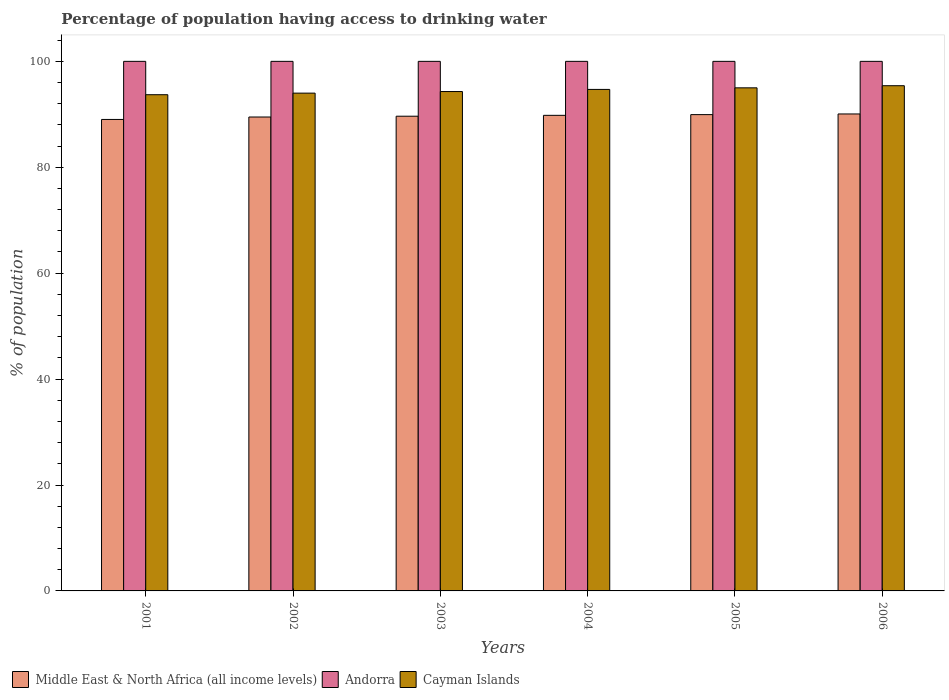How many groups of bars are there?
Offer a very short reply. 6. What is the percentage of population having access to drinking water in Andorra in 2001?
Keep it short and to the point. 100. Across all years, what is the maximum percentage of population having access to drinking water in Cayman Islands?
Your answer should be very brief. 95.4. Across all years, what is the minimum percentage of population having access to drinking water in Middle East & North Africa (all income levels)?
Offer a very short reply. 89.03. In which year was the percentage of population having access to drinking water in Andorra minimum?
Ensure brevity in your answer.  2001. What is the total percentage of population having access to drinking water in Cayman Islands in the graph?
Your answer should be compact. 567.1. What is the difference between the percentage of population having access to drinking water in Middle East & North Africa (all income levels) in 2002 and that in 2006?
Provide a short and direct response. -0.58. What is the average percentage of population having access to drinking water in Middle East & North Africa (all income levels) per year?
Keep it short and to the point. 89.66. In the year 2003, what is the difference between the percentage of population having access to drinking water in Andorra and percentage of population having access to drinking water in Middle East & North Africa (all income levels)?
Provide a short and direct response. 10.36. In how many years, is the percentage of population having access to drinking water in Cayman Islands greater than 8 %?
Ensure brevity in your answer.  6. What is the ratio of the percentage of population having access to drinking water in Andorra in 2001 to that in 2005?
Provide a short and direct response. 1. Is the difference between the percentage of population having access to drinking water in Andorra in 2002 and 2004 greater than the difference between the percentage of population having access to drinking water in Middle East & North Africa (all income levels) in 2002 and 2004?
Your answer should be very brief. Yes. What is the difference between the highest and the lowest percentage of population having access to drinking water in Middle East & North Africa (all income levels)?
Offer a terse response. 1.04. What does the 3rd bar from the left in 2004 represents?
Your answer should be very brief. Cayman Islands. What does the 3rd bar from the right in 2006 represents?
Provide a short and direct response. Middle East & North Africa (all income levels). Is it the case that in every year, the sum of the percentage of population having access to drinking water in Middle East & North Africa (all income levels) and percentage of population having access to drinking water in Andorra is greater than the percentage of population having access to drinking water in Cayman Islands?
Make the answer very short. Yes. Are all the bars in the graph horizontal?
Your answer should be compact. No. What is the difference between two consecutive major ticks on the Y-axis?
Give a very brief answer. 20. Does the graph contain any zero values?
Your response must be concise. No. How are the legend labels stacked?
Offer a terse response. Horizontal. What is the title of the graph?
Your response must be concise. Percentage of population having access to drinking water. What is the label or title of the Y-axis?
Your answer should be very brief. % of population. What is the % of population in Middle East & North Africa (all income levels) in 2001?
Give a very brief answer. 89.03. What is the % of population of Andorra in 2001?
Keep it short and to the point. 100. What is the % of population in Cayman Islands in 2001?
Your answer should be very brief. 93.7. What is the % of population of Middle East & North Africa (all income levels) in 2002?
Provide a short and direct response. 89.49. What is the % of population of Andorra in 2002?
Your answer should be compact. 100. What is the % of population of Cayman Islands in 2002?
Keep it short and to the point. 94. What is the % of population in Middle East & North Africa (all income levels) in 2003?
Ensure brevity in your answer.  89.64. What is the % of population in Andorra in 2003?
Your answer should be very brief. 100. What is the % of population of Cayman Islands in 2003?
Make the answer very short. 94.3. What is the % of population in Middle East & North Africa (all income levels) in 2004?
Your answer should be very brief. 89.81. What is the % of population in Andorra in 2004?
Keep it short and to the point. 100. What is the % of population of Cayman Islands in 2004?
Keep it short and to the point. 94.7. What is the % of population of Middle East & North Africa (all income levels) in 2005?
Keep it short and to the point. 89.94. What is the % of population of Andorra in 2005?
Your answer should be very brief. 100. What is the % of population of Cayman Islands in 2005?
Offer a terse response. 95. What is the % of population in Middle East & North Africa (all income levels) in 2006?
Keep it short and to the point. 90.07. What is the % of population in Cayman Islands in 2006?
Your response must be concise. 95.4. Across all years, what is the maximum % of population of Middle East & North Africa (all income levels)?
Ensure brevity in your answer.  90.07. Across all years, what is the maximum % of population of Andorra?
Make the answer very short. 100. Across all years, what is the maximum % of population in Cayman Islands?
Give a very brief answer. 95.4. Across all years, what is the minimum % of population in Middle East & North Africa (all income levels)?
Provide a short and direct response. 89.03. Across all years, what is the minimum % of population in Andorra?
Your answer should be compact. 100. Across all years, what is the minimum % of population of Cayman Islands?
Give a very brief answer. 93.7. What is the total % of population of Middle East & North Africa (all income levels) in the graph?
Offer a very short reply. 537.98. What is the total % of population in Andorra in the graph?
Provide a succinct answer. 600. What is the total % of population of Cayman Islands in the graph?
Ensure brevity in your answer.  567.1. What is the difference between the % of population of Middle East & North Africa (all income levels) in 2001 and that in 2002?
Ensure brevity in your answer.  -0.46. What is the difference between the % of population of Andorra in 2001 and that in 2002?
Your answer should be very brief. 0. What is the difference between the % of population in Middle East & North Africa (all income levels) in 2001 and that in 2003?
Give a very brief answer. -0.61. What is the difference between the % of population in Middle East & North Africa (all income levels) in 2001 and that in 2004?
Make the answer very short. -0.78. What is the difference between the % of population of Andorra in 2001 and that in 2004?
Give a very brief answer. 0. What is the difference between the % of population of Middle East & North Africa (all income levels) in 2001 and that in 2005?
Make the answer very short. -0.91. What is the difference between the % of population in Andorra in 2001 and that in 2005?
Give a very brief answer. 0. What is the difference between the % of population of Middle East & North Africa (all income levels) in 2001 and that in 2006?
Offer a terse response. -1.04. What is the difference between the % of population in Middle East & North Africa (all income levels) in 2002 and that in 2003?
Provide a succinct answer. -0.15. What is the difference between the % of population in Middle East & North Africa (all income levels) in 2002 and that in 2004?
Your answer should be compact. -0.32. What is the difference between the % of population in Andorra in 2002 and that in 2004?
Provide a succinct answer. 0. What is the difference between the % of population of Cayman Islands in 2002 and that in 2004?
Your answer should be very brief. -0.7. What is the difference between the % of population of Middle East & North Africa (all income levels) in 2002 and that in 2005?
Ensure brevity in your answer.  -0.45. What is the difference between the % of population in Cayman Islands in 2002 and that in 2005?
Offer a terse response. -1. What is the difference between the % of population in Middle East & North Africa (all income levels) in 2002 and that in 2006?
Provide a succinct answer. -0.58. What is the difference between the % of population of Cayman Islands in 2002 and that in 2006?
Make the answer very short. -1.4. What is the difference between the % of population in Middle East & North Africa (all income levels) in 2003 and that in 2004?
Your answer should be compact. -0.17. What is the difference between the % of population in Andorra in 2003 and that in 2004?
Ensure brevity in your answer.  0. What is the difference between the % of population of Middle East & North Africa (all income levels) in 2003 and that in 2005?
Keep it short and to the point. -0.3. What is the difference between the % of population in Middle East & North Africa (all income levels) in 2003 and that in 2006?
Offer a very short reply. -0.43. What is the difference between the % of population of Andorra in 2003 and that in 2006?
Ensure brevity in your answer.  0. What is the difference between the % of population of Middle East & North Africa (all income levels) in 2004 and that in 2005?
Your answer should be very brief. -0.13. What is the difference between the % of population in Andorra in 2004 and that in 2005?
Provide a succinct answer. 0. What is the difference between the % of population in Cayman Islands in 2004 and that in 2005?
Give a very brief answer. -0.3. What is the difference between the % of population in Middle East & North Africa (all income levels) in 2004 and that in 2006?
Provide a succinct answer. -0.26. What is the difference between the % of population of Cayman Islands in 2004 and that in 2006?
Offer a terse response. -0.7. What is the difference between the % of population in Middle East & North Africa (all income levels) in 2005 and that in 2006?
Provide a succinct answer. -0.13. What is the difference between the % of population in Andorra in 2005 and that in 2006?
Provide a short and direct response. 0. What is the difference between the % of population in Middle East & North Africa (all income levels) in 2001 and the % of population in Andorra in 2002?
Ensure brevity in your answer.  -10.97. What is the difference between the % of population in Middle East & North Africa (all income levels) in 2001 and the % of population in Cayman Islands in 2002?
Your response must be concise. -4.97. What is the difference between the % of population in Andorra in 2001 and the % of population in Cayman Islands in 2002?
Offer a very short reply. 6. What is the difference between the % of population in Middle East & North Africa (all income levels) in 2001 and the % of population in Andorra in 2003?
Ensure brevity in your answer.  -10.97. What is the difference between the % of population in Middle East & North Africa (all income levels) in 2001 and the % of population in Cayman Islands in 2003?
Offer a terse response. -5.27. What is the difference between the % of population in Middle East & North Africa (all income levels) in 2001 and the % of population in Andorra in 2004?
Your response must be concise. -10.97. What is the difference between the % of population in Middle East & North Africa (all income levels) in 2001 and the % of population in Cayman Islands in 2004?
Give a very brief answer. -5.67. What is the difference between the % of population of Andorra in 2001 and the % of population of Cayman Islands in 2004?
Make the answer very short. 5.3. What is the difference between the % of population of Middle East & North Africa (all income levels) in 2001 and the % of population of Andorra in 2005?
Give a very brief answer. -10.97. What is the difference between the % of population in Middle East & North Africa (all income levels) in 2001 and the % of population in Cayman Islands in 2005?
Provide a short and direct response. -5.97. What is the difference between the % of population of Andorra in 2001 and the % of population of Cayman Islands in 2005?
Offer a very short reply. 5. What is the difference between the % of population in Middle East & North Africa (all income levels) in 2001 and the % of population in Andorra in 2006?
Your response must be concise. -10.97. What is the difference between the % of population in Middle East & North Africa (all income levels) in 2001 and the % of population in Cayman Islands in 2006?
Ensure brevity in your answer.  -6.37. What is the difference between the % of population of Middle East & North Africa (all income levels) in 2002 and the % of population of Andorra in 2003?
Provide a short and direct response. -10.51. What is the difference between the % of population in Middle East & North Africa (all income levels) in 2002 and the % of population in Cayman Islands in 2003?
Offer a terse response. -4.81. What is the difference between the % of population in Andorra in 2002 and the % of population in Cayman Islands in 2003?
Offer a very short reply. 5.7. What is the difference between the % of population in Middle East & North Africa (all income levels) in 2002 and the % of population in Andorra in 2004?
Make the answer very short. -10.51. What is the difference between the % of population in Middle East & North Africa (all income levels) in 2002 and the % of population in Cayman Islands in 2004?
Make the answer very short. -5.21. What is the difference between the % of population in Andorra in 2002 and the % of population in Cayman Islands in 2004?
Ensure brevity in your answer.  5.3. What is the difference between the % of population of Middle East & North Africa (all income levels) in 2002 and the % of population of Andorra in 2005?
Your answer should be very brief. -10.51. What is the difference between the % of population of Middle East & North Africa (all income levels) in 2002 and the % of population of Cayman Islands in 2005?
Your response must be concise. -5.51. What is the difference between the % of population of Andorra in 2002 and the % of population of Cayman Islands in 2005?
Keep it short and to the point. 5. What is the difference between the % of population in Middle East & North Africa (all income levels) in 2002 and the % of population in Andorra in 2006?
Your answer should be compact. -10.51. What is the difference between the % of population of Middle East & North Africa (all income levels) in 2002 and the % of population of Cayman Islands in 2006?
Provide a short and direct response. -5.91. What is the difference between the % of population in Andorra in 2002 and the % of population in Cayman Islands in 2006?
Give a very brief answer. 4.6. What is the difference between the % of population of Middle East & North Africa (all income levels) in 2003 and the % of population of Andorra in 2004?
Ensure brevity in your answer.  -10.36. What is the difference between the % of population of Middle East & North Africa (all income levels) in 2003 and the % of population of Cayman Islands in 2004?
Provide a short and direct response. -5.06. What is the difference between the % of population in Andorra in 2003 and the % of population in Cayman Islands in 2004?
Your answer should be very brief. 5.3. What is the difference between the % of population in Middle East & North Africa (all income levels) in 2003 and the % of population in Andorra in 2005?
Give a very brief answer. -10.36. What is the difference between the % of population of Middle East & North Africa (all income levels) in 2003 and the % of population of Cayman Islands in 2005?
Offer a very short reply. -5.36. What is the difference between the % of population in Middle East & North Africa (all income levels) in 2003 and the % of population in Andorra in 2006?
Offer a very short reply. -10.36. What is the difference between the % of population in Middle East & North Africa (all income levels) in 2003 and the % of population in Cayman Islands in 2006?
Your answer should be compact. -5.76. What is the difference between the % of population in Middle East & North Africa (all income levels) in 2004 and the % of population in Andorra in 2005?
Offer a terse response. -10.19. What is the difference between the % of population in Middle East & North Africa (all income levels) in 2004 and the % of population in Cayman Islands in 2005?
Ensure brevity in your answer.  -5.19. What is the difference between the % of population of Andorra in 2004 and the % of population of Cayman Islands in 2005?
Your response must be concise. 5. What is the difference between the % of population in Middle East & North Africa (all income levels) in 2004 and the % of population in Andorra in 2006?
Keep it short and to the point. -10.19. What is the difference between the % of population in Middle East & North Africa (all income levels) in 2004 and the % of population in Cayman Islands in 2006?
Provide a short and direct response. -5.59. What is the difference between the % of population of Middle East & North Africa (all income levels) in 2005 and the % of population of Andorra in 2006?
Provide a succinct answer. -10.06. What is the difference between the % of population of Middle East & North Africa (all income levels) in 2005 and the % of population of Cayman Islands in 2006?
Give a very brief answer. -5.46. What is the average % of population of Middle East & North Africa (all income levels) per year?
Your answer should be very brief. 89.66. What is the average % of population of Cayman Islands per year?
Offer a terse response. 94.52. In the year 2001, what is the difference between the % of population of Middle East & North Africa (all income levels) and % of population of Andorra?
Provide a succinct answer. -10.97. In the year 2001, what is the difference between the % of population in Middle East & North Africa (all income levels) and % of population in Cayman Islands?
Give a very brief answer. -4.67. In the year 2001, what is the difference between the % of population in Andorra and % of population in Cayman Islands?
Your answer should be compact. 6.3. In the year 2002, what is the difference between the % of population of Middle East & North Africa (all income levels) and % of population of Andorra?
Ensure brevity in your answer.  -10.51. In the year 2002, what is the difference between the % of population in Middle East & North Africa (all income levels) and % of population in Cayman Islands?
Your answer should be very brief. -4.51. In the year 2002, what is the difference between the % of population in Andorra and % of population in Cayman Islands?
Your answer should be very brief. 6. In the year 2003, what is the difference between the % of population of Middle East & North Africa (all income levels) and % of population of Andorra?
Provide a short and direct response. -10.36. In the year 2003, what is the difference between the % of population in Middle East & North Africa (all income levels) and % of population in Cayman Islands?
Keep it short and to the point. -4.66. In the year 2004, what is the difference between the % of population in Middle East & North Africa (all income levels) and % of population in Andorra?
Make the answer very short. -10.19. In the year 2004, what is the difference between the % of population in Middle East & North Africa (all income levels) and % of population in Cayman Islands?
Ensure brevity in your answer.  -4.89. In the year 2005, what is the difference between the % of population of Middle East & North Africa (all income levels) and % of population of Andorra?
Give a very brief answer. -10.06. In the year 2005, what is the difference between the % of population of Middle East & North Africa (all income levels) and % of population of Cayman Islands?
Ensure brevity in your answer.  -5.06. In the year 2005, what is the difference between the % of population in Andorra and % of population in Cayman Islands?
Offer a terse response. 5. In the year 2006, what is the difference between the % of population of Middle East & North Africa (all income levels) and % of population of Andorra?
Your answer should be compact. -9.93. In the year 2006, what is the difference between the % of population in Middle East & North Africa (all income levels) and % of population in Cayman Islands?
Your response must be concise. -5.33. What is the ratio of the % of population of Andorra in 2001 to that in 2002?
Provide a short and direct response. 1. What is the ratio of the % of population of Cayman Islands in 2001 to that in 2002?
Give a very brief answer. 1. What is the ratio of the % of population in Cayman Islands in 2001 to that in 2003?
Keep it short and to the point. 0.99. What is the ratio of the % of population in Middle East & North Africa (all income levels) in 2001 to that in 2004?
Your response must be concise. 0.99. What is the ratio of the % of population of Andorra in 2001 to that in 2004?
Provide a short and direct response. 1. What is the ratio of the % of population in Middle East & North Africa (all income levels) in 2001 to that in 2005?
Your answer should be compact. 0.99. What is the ratio of the % of population in Cayman Islands in 2001 to that in 2005?
Provide a short and direct response. 0.99. What is the ratio of the % of population in Andorra in 2001 to that in 2006?
Ensure brevity in your answer.  1. What is the ratio of the % of population of Cayman Islands in 2001 to that in 2006?
Provide a succinct answer. 0.98. What is the ratio of the % of population of Middle East & North Africa (all income levels) in 2002 to that in 2004?
Your answer should be very brief. 1. What is the ratio of the % of population in Andorra in 2002 to that in 2004?
Your answer should be compact. 1. What is the ratio of the % of population of Cayman Islands in 2002 to that in 2004?
Keep it short and to the point. 0.99. What is the ratio of the % of population in Middle East & North Africa (all income levels) in 2002 to that in 2005?
Your response must be concise. 0.99. What is the ratio of the % of population of Cayman Islands in 2002 to that in 2005?
Provide a short and direct response. 0.99. What is the ratio of the % of population in Andorra in 2002 to that in 2006?
Offer a very short reply. 1. What is the ratio of the % of population in Middle East & North Africa (all income levels) in 2003 to that in 2004?
Offer a terse response. 1. What is the ratio of the % of population in Andorra in 2003 to that in 2004?
Keep it short and to the point. 1. What is the ratio of the % of population in Cayman Islands in 2003 to that in 2004?
Offer a very short reply. 1. What is the ratio of the % of population in Middle East & North Africa (all income levels) in 2003 to that in 2006?
Offer a terse response. 1. What is the ratio of the % of population of Middle East & North Africa (all income levels) in 2004 to that in 2006?
Make the answer very short. 1. What is the ratio of the % of population of Cayman Islands in 2004 to that in 2006?
Your response must be concise. 0.99. What is the ratio of the % of population in Middle East & North Africa (all income levels) in 2005 to that in 2006?
Keep it short and to the point. 1. What is the difference between the highest and the second highest % of population of Middle East & North Africa (all income levels)?
Provide a short and direct response. 0.13. What is the difference between the highest and the second highest % of population of Andorra?
Provide a short and direct response. 0. What is the difference between the highest and the second highest % of population in Cayman Islands?
Ensure brevity in your answer.  0.4. What is the difference between the highest and the lowest % of population of Middle East & North Africa (all income levels)?
Keep it short and to the point. 1.04. What is the difference between the highest and the lowest % of population of Cayman Islands?
Keep it short and to the point. 1.7. 